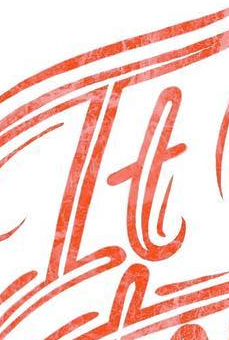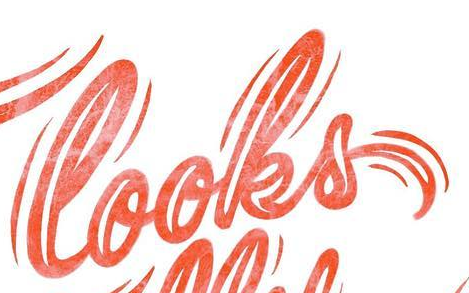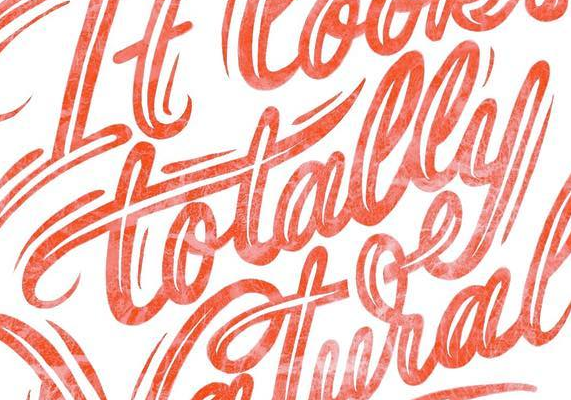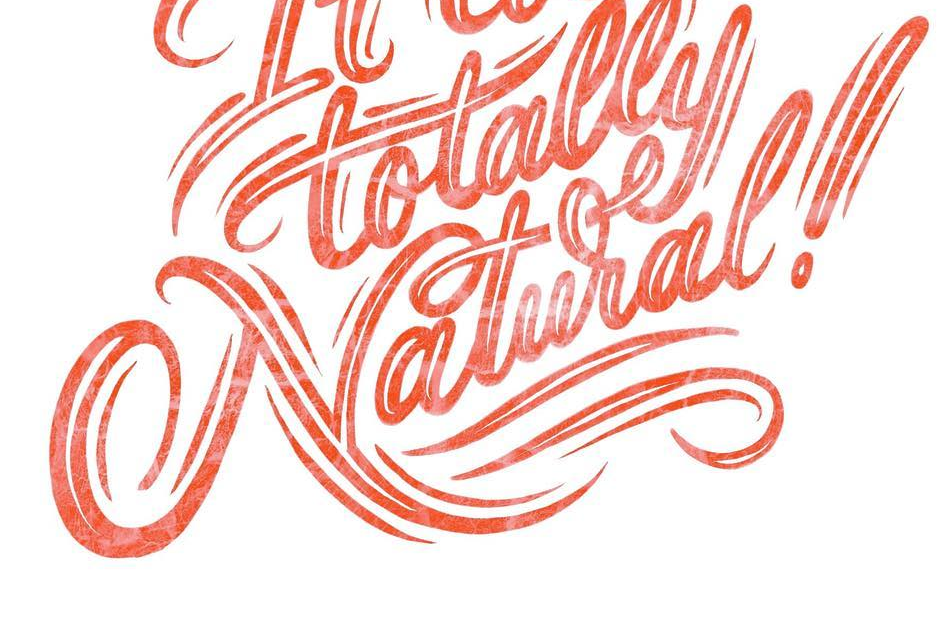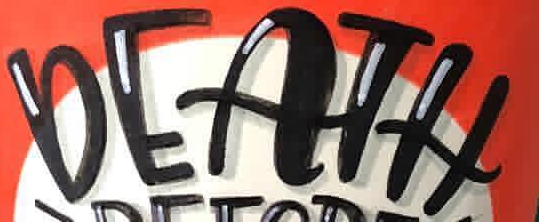Transcribe the words shown in these images in order, separated by a semicolon. It; looks; totally; Natural!; DEATH 